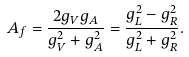<formula> <loc_0><loc_0><loc_500><loc_500>A _ { f } = \frac { 2 g _ { V } g _ { A } } { g ^ { 2 } _ { V } + g ^ { 2 } _ { A } } = \frac { g ^ { 2 } _ { L } - g ^ { 2 } _ { R } } { g ^ { 2 } _ { L } + g ^ { 2 } _ { R } } .</formula> 